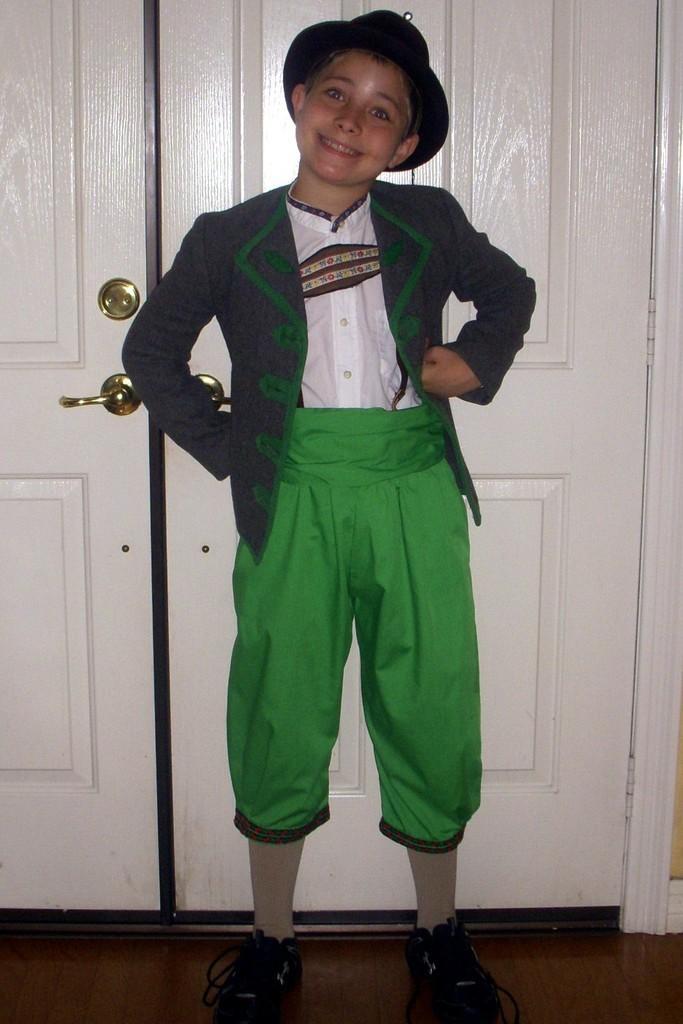Could you give a brief overview of what you see in this image? In this image we can see a boy wearing the hat and smiling and also standing on the floor. In the background we can see the white doors. 